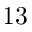<formula> <loc_0><loc_0><loc_500><loc_500>1 3</formula> 